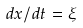Convert formula to latex. <formula><loc_0><loc_0><loc_500><loc_500>d x / d t = \xi</formula> 